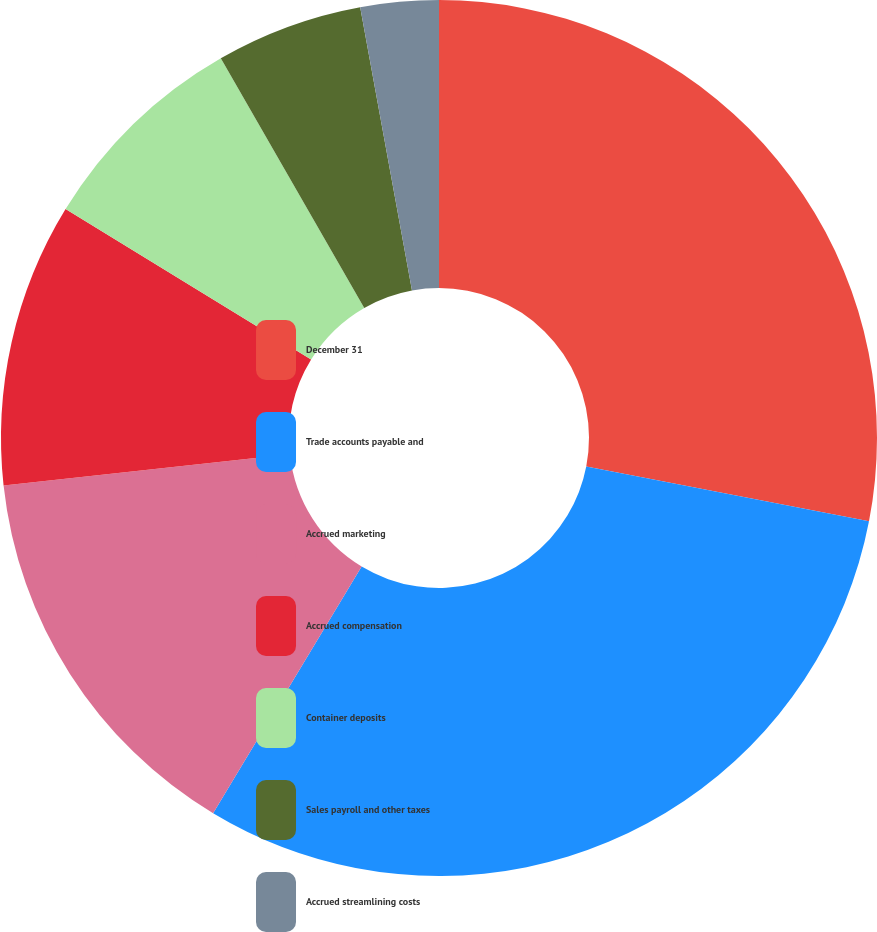Convert chart to OTSL. <chart><loc_0><loc_0><loc_500><loc_500><pie_chart><fcel>December 31<fcel>Trade accounts payable and<fcel>Accrued marketing<fcel>Accrued compensation<fcel>Container deposits<fcel>Sales payroll and other taxes<fcel>Accrued streamlining costs<nl><fcel>28.05%<fcel>30.58%<fcel>14.65%<fcel>10.48%<fcel>7.95%<fcel>5.42%<fcel>2.88%<nl></chart> 